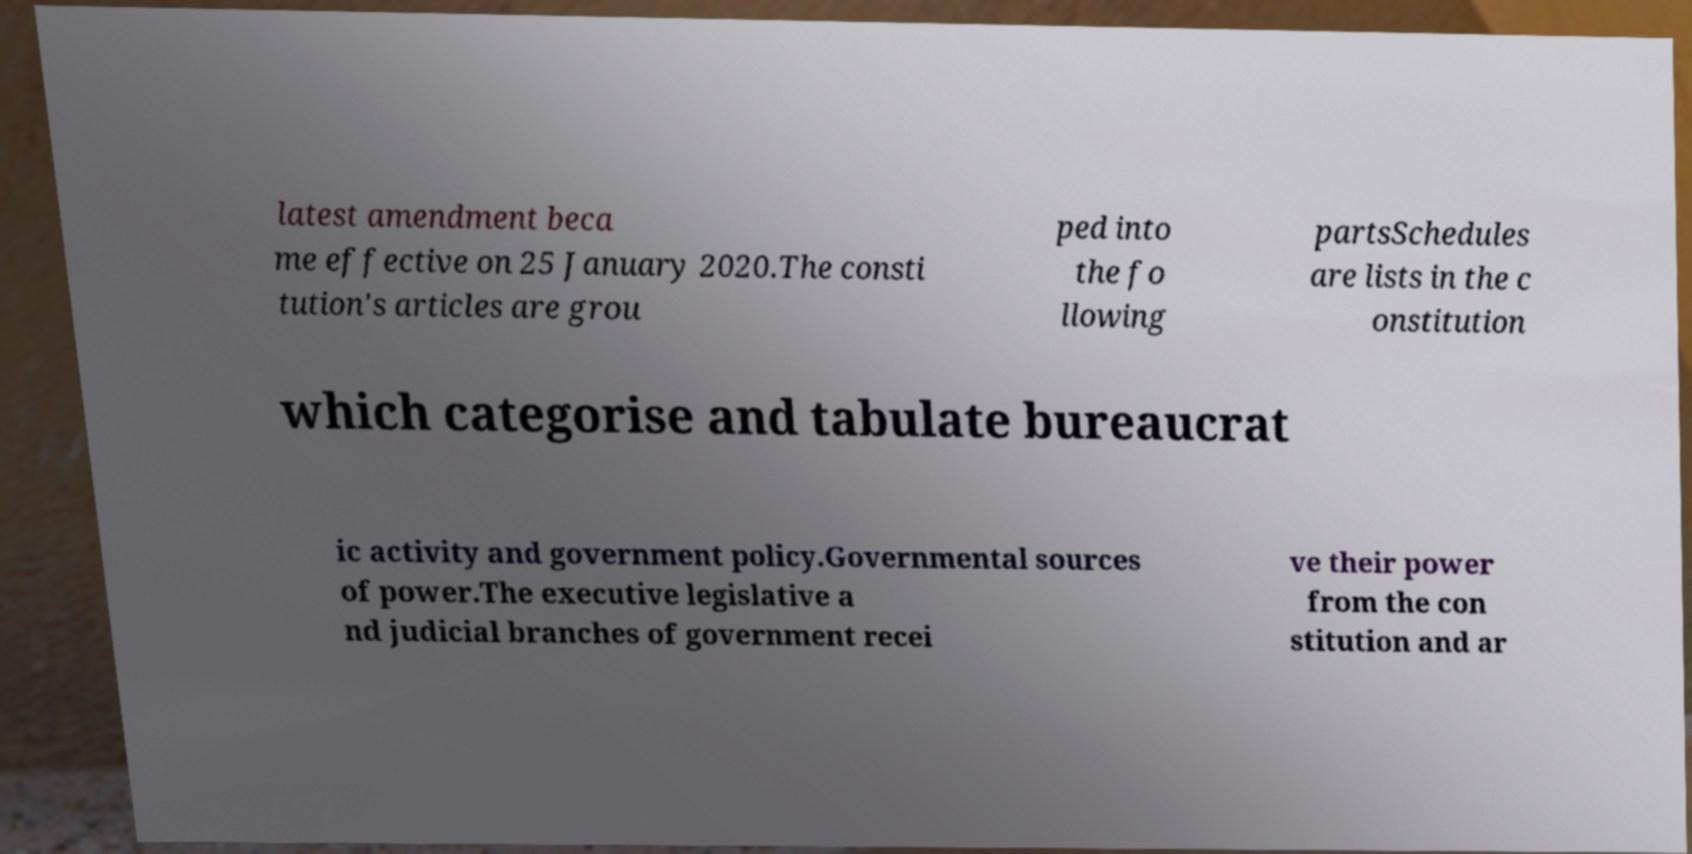Can you accurately transcribe the text from the provided image for me? latest amendment beca me effective on 25 January 2020.The consti tution's articles are grou ped into the fo llowing partsSchedules are lists in the c onstitution which categorise and tabulate bureaucrat ic activity and government policy.Governmental sources of power.The executive legislative a nd judicial branches of government recei ve their power from the con stitution and ar 